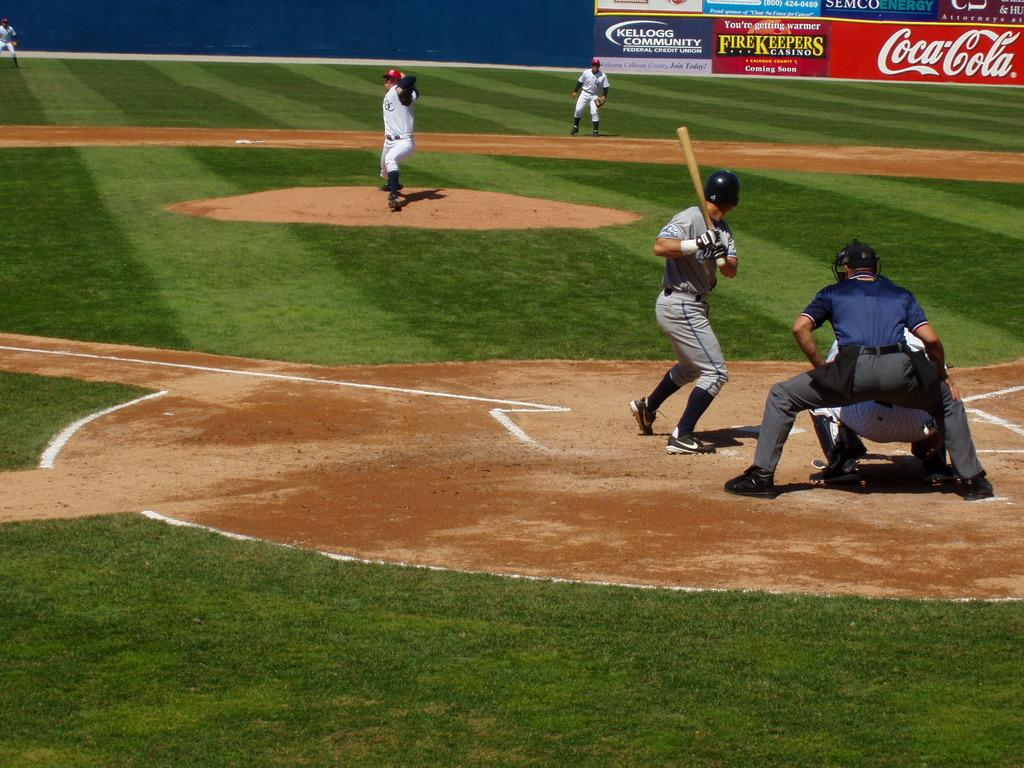Provide a one-sentence caption for the provided image. some players getting ready to play with a Coca Cola advertisement in the outfield. 